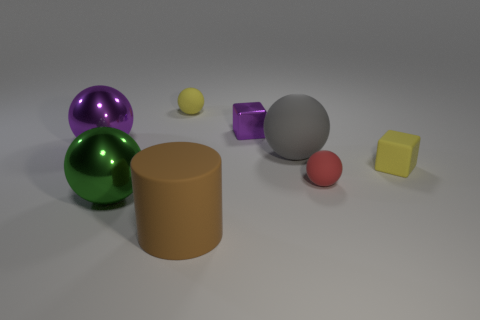Subtract all big purple metallic spheres. How many spheres are left? 4 Add 1 small yellow matte things. How many objects exist? 9 Subtract all green spheres. How many spheres are left? 4 Subtract 0 blue spheres. How many objects are left? 8 Subtract all blocks. How many objects are left? 6 Subtract 1 cubes. How many cubes are left? 1 Subtract all brown balls. Subtract all gray cylinders. How many balls are left? 5 Subtract all green blocks. How many green spheres are left? 1 Subtract all large shiny balls. Subtract all small purple metallic objects. How many objects are left? 5 Add 1 gray rubber objects. How many gray rubber objects are left? 2 